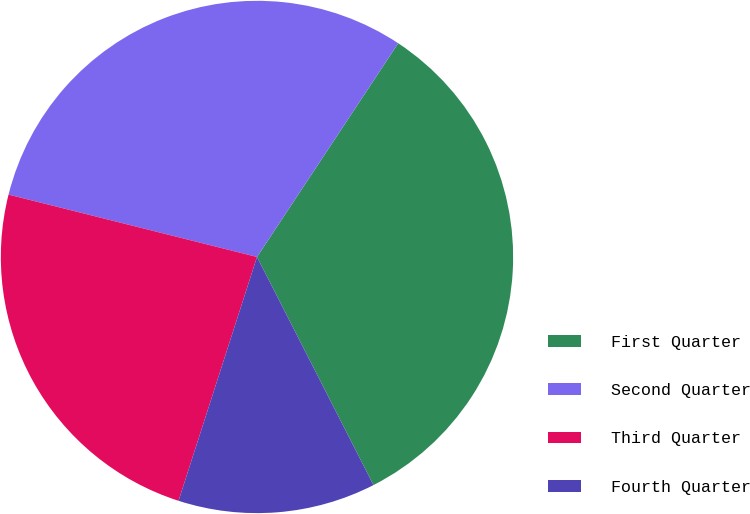Convert chart to OTSL. <chart><loc_0><loc_0><loc_500><loc_500><pie_chart><fcel>First Quarter<fcel>Second Quarter<fcel>Third Quarter<fcel>Fourth Quarter<nl><fcel>33.19%<fcel>30.38%<fcel>23.96%<fcel>12.47%<nl></chart> 